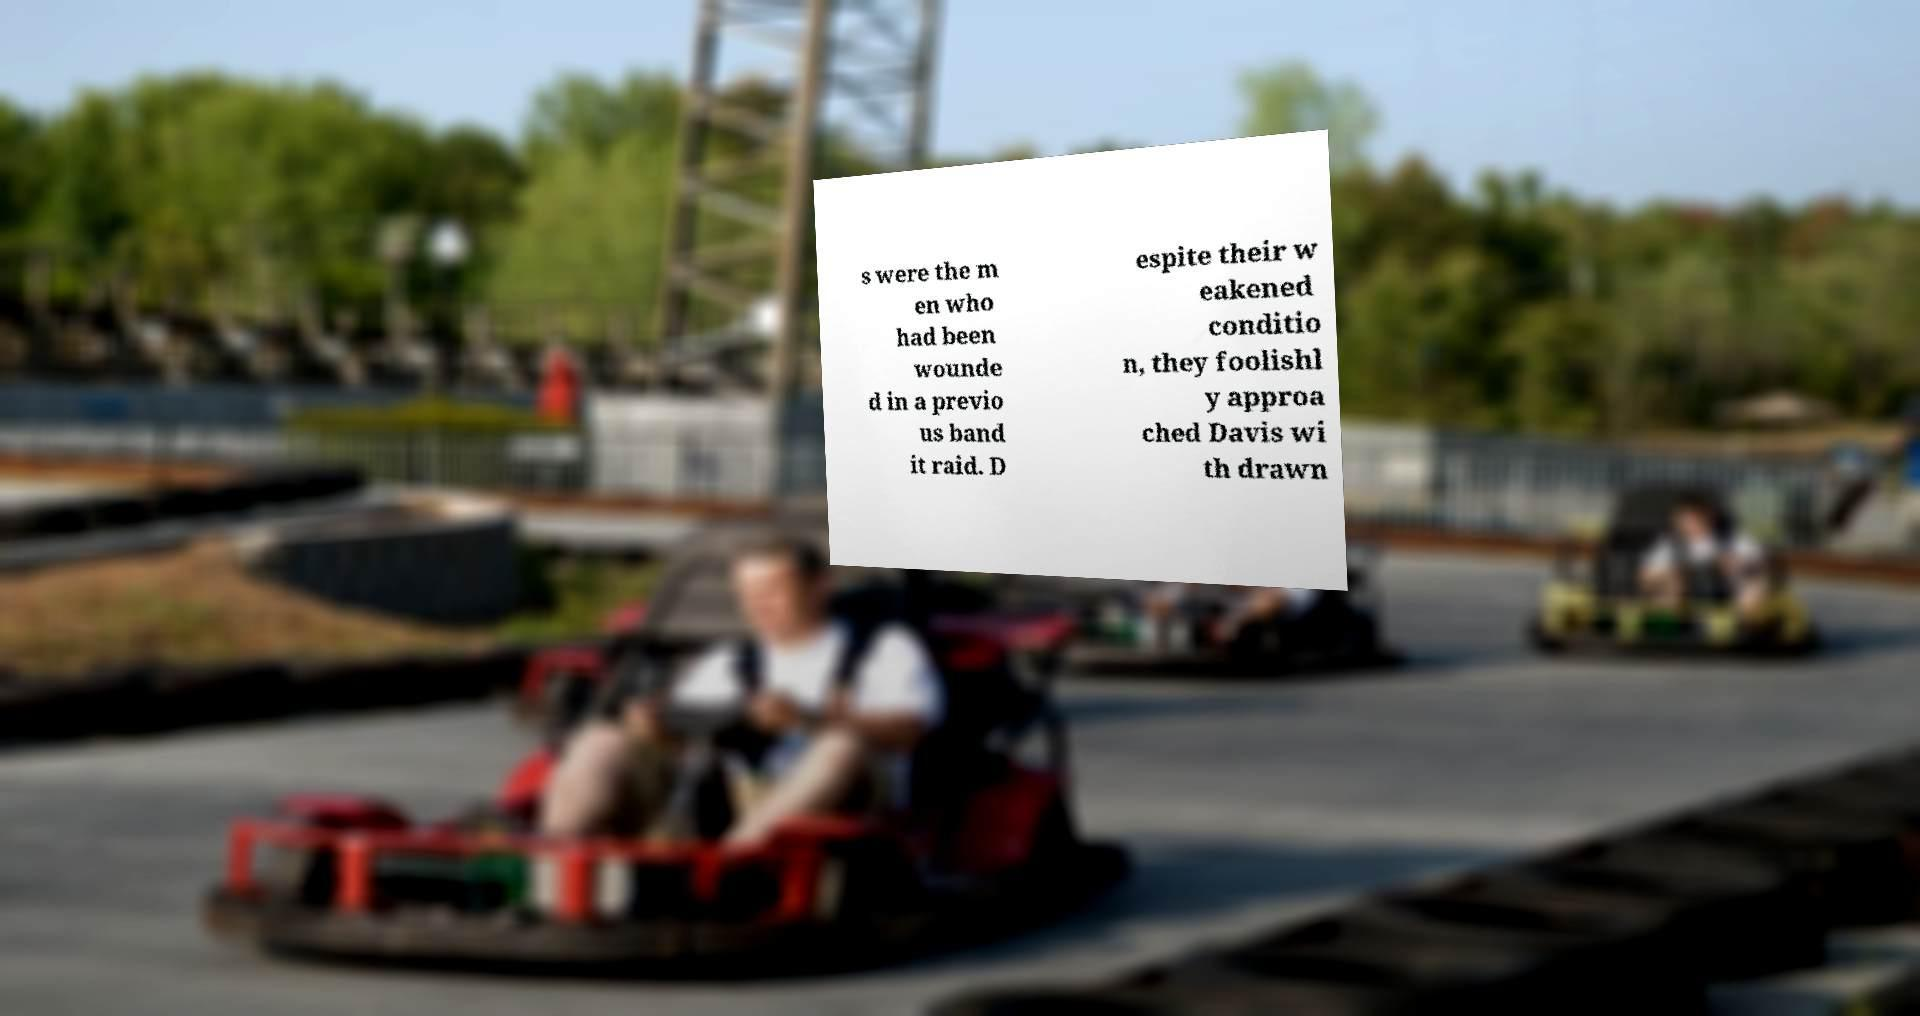Can you accurately transcribe the text from the provided image for me? s were the m en who had been wounde d in a previo us band it raid. D espite their w eakened conditio n, they foolishl y approa ched Davis wi th drawn 